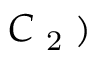<formula> <loc_0><loc_0><loc_500><loc_500>C \text  subscript { 2 } )</formula> 